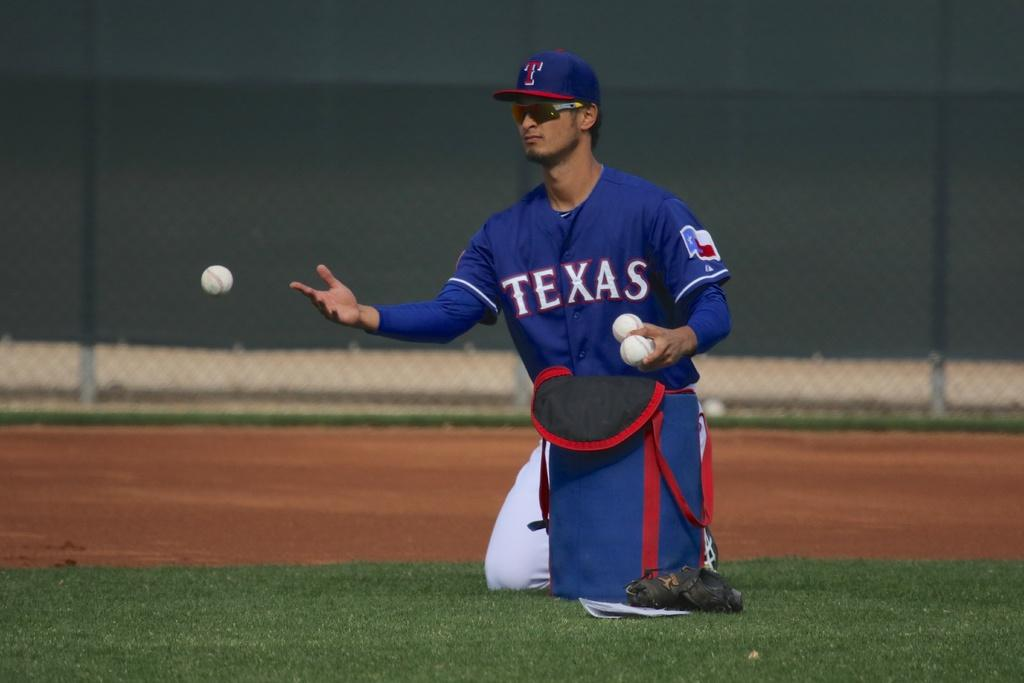<image>
Write a terse but informative summary of the picture. A baseball player for Texas is catching a ball. 